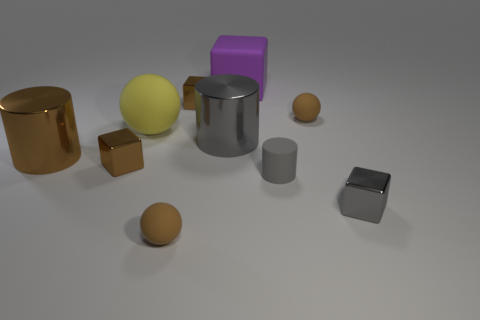Are the brown cylinder and the brown thing right of the purple object made of the same material?
Make the answer very short. No. What number of things are big purple objects or large metal cylinders?
Your answer should be very brief. 3. Is there a small gray cylinder?
Keep it short and to the point. Yes. There is a tiny brown matte thing right of the brown ball that is in front of the large brown thing; what shape is it?
Ensure brevity in your answer.  Sphere. How many objects are either shiny objects that are behind the large yellow matte sphere or rubber spheres that are on the left side of the large purple rubber block?
Make the answer very short. 3. There is a brown cylinder that is the same size as the yellow rubber thing; what material is it?
Your response must be concise. Metal. What color is the rubber block?
Make the answer very short. Purple. The cube that is left of the big purple object and behind the large yellow thing is made of what material?
Provide a succinct answer. Metal. Is there a rubber ball that is to the right of the small shiny cube left of the brown ball in front of the gray matte object?
Make the answer very short. Yes. The metallic cylinder that is the same color as the matte cylinder is what size?
Offer a terse response. Large. 